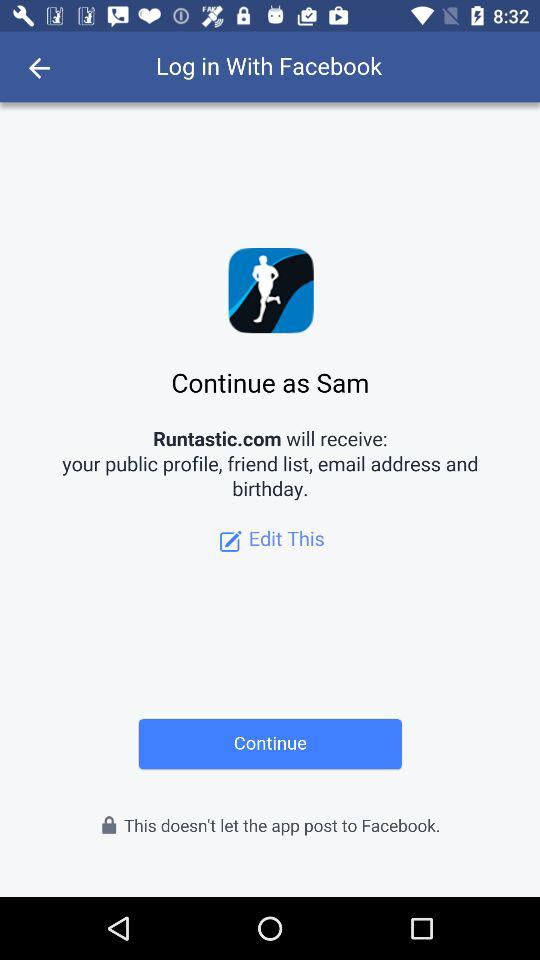What application is asking for permission? The application asking for permission is "Runtastic.com". 